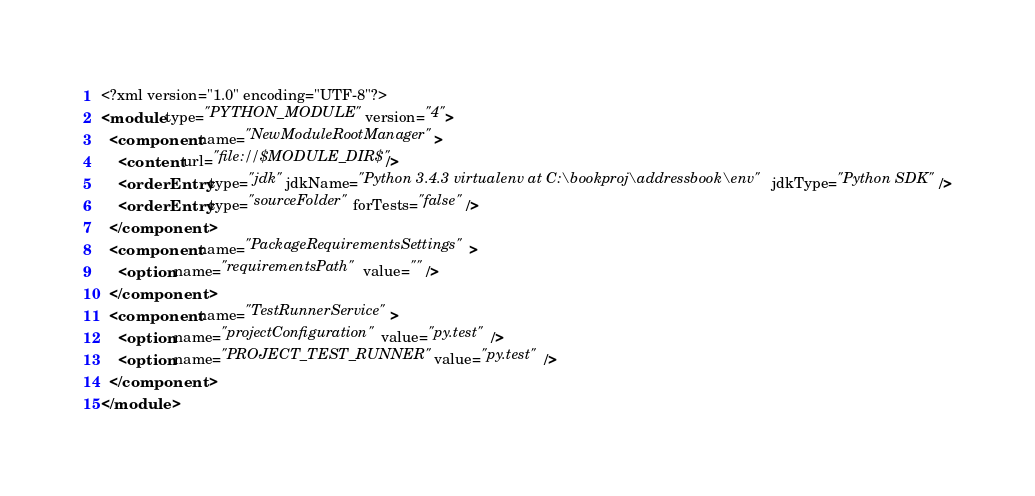<code> <loc_0><loc_0><loc_500><loc_500><_XML_><?xml version="1.0" encoding="UTF-8"?>
<module type="PYTHON_MODULE" version="4">
  <component name="NewModuleRootManager">
    <content url="file://$MODULE_DIR$" />
    <orderEntry type="jdk" jdkName="Python 3.4.3 virtualenv at C:\bookproj\addressbook\env" jdkType="Python SDK" />
    <orderEntry type="sourceFolder" forTests="false" />
  </component>
  <component name="PackageRequirementsSettings">
    <option name="requirementsPath" value="" />
  </component>
  <component name="TestRunnerService">
    <option name="projectConfiguration" value="py.test" />
    <option name="PROJECT_TEST_RUNNER" value="py.test" />
  </component>
</module></code> 